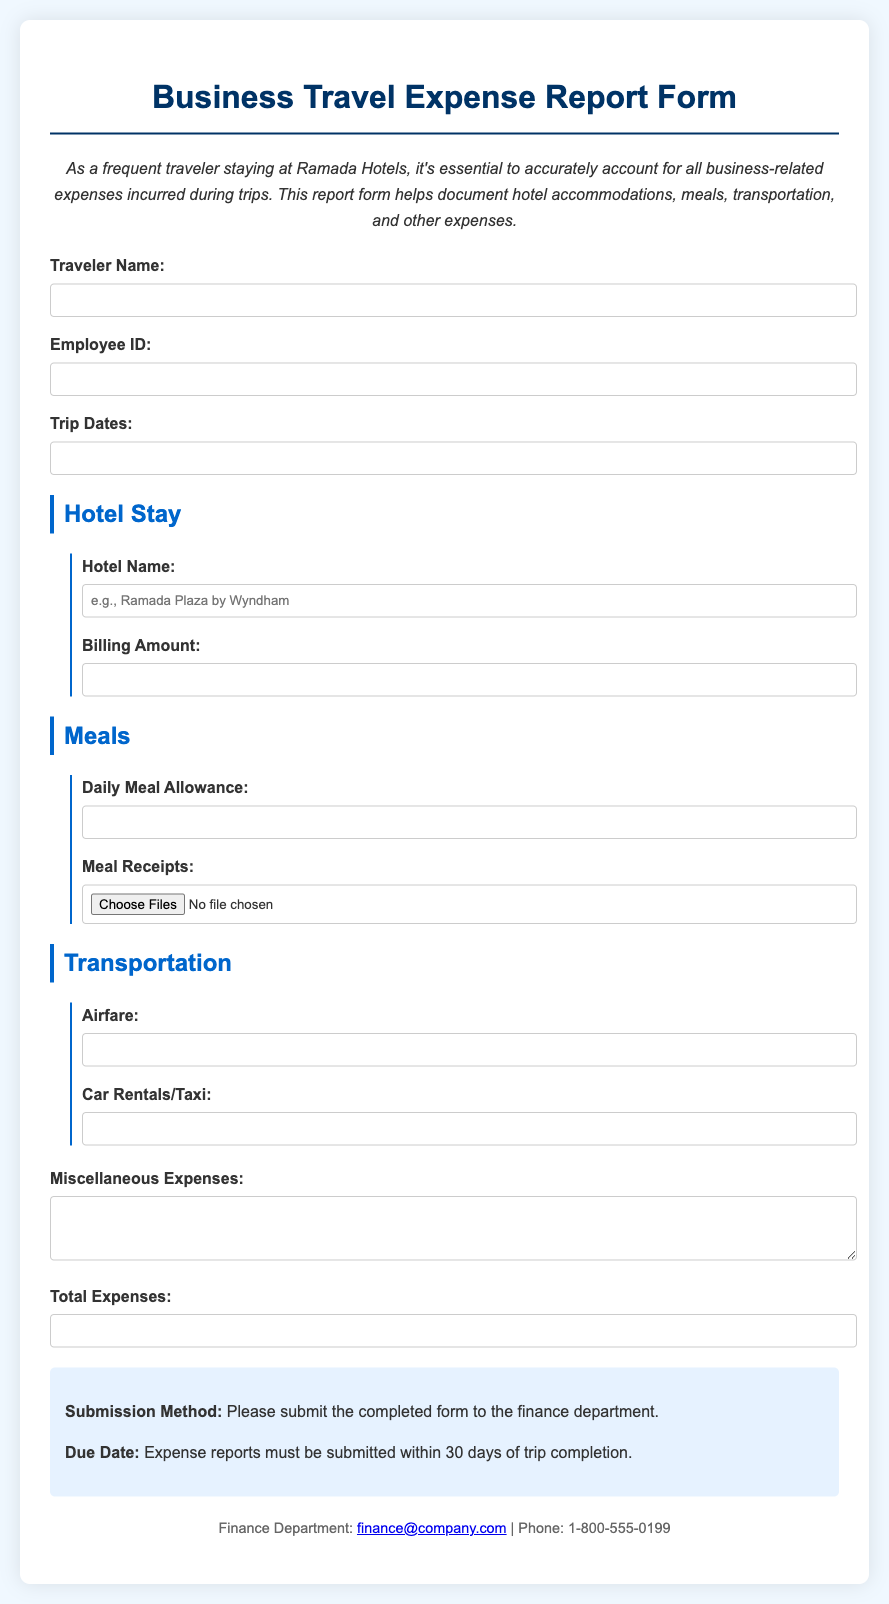What is the title of the document? The title is presented at the top of the document and states "Business Travel Expense Report Form".
Answer: Business Travel Expense Report Form What is the required information for the traveler name? The traveler name is a mandatory field that needs to be filled in the report form.
Answer: Traveler Name What is the required document submission timeline? The submission timeline indicates that reports should be submitted within 30 days of trip completion.
Answer: 30 days What type of hotel does the form suggest for travelers? The form mentions Ramada Hotels in the introduction as the preferred accommodation.
Answer: Ramada Hotels What is the maximum file type allowed for meal receipts? The form allows for multiple files to be submitted for meal receipts, indicating it supports various file types.
Answer: Multiple files How is the total expenses field labeled? The total expenses field is clearly labeled for the user to input the sum of all expenses.
Answer: Total Expenses What contact method is provided for the finance department? The contact information includes an email address and a phone number for the finance department.
Answer: finance@company.com What is the daily meal allowance in the form? It is indicated that there is a field for entering a daily meal allowance in the report form.
Answer: Daily Meal Allowance What does the hotel billing amount field require? The hotel billing amount field is a numeric input required for documenting hotel expenses.
Answer: Numeric input 